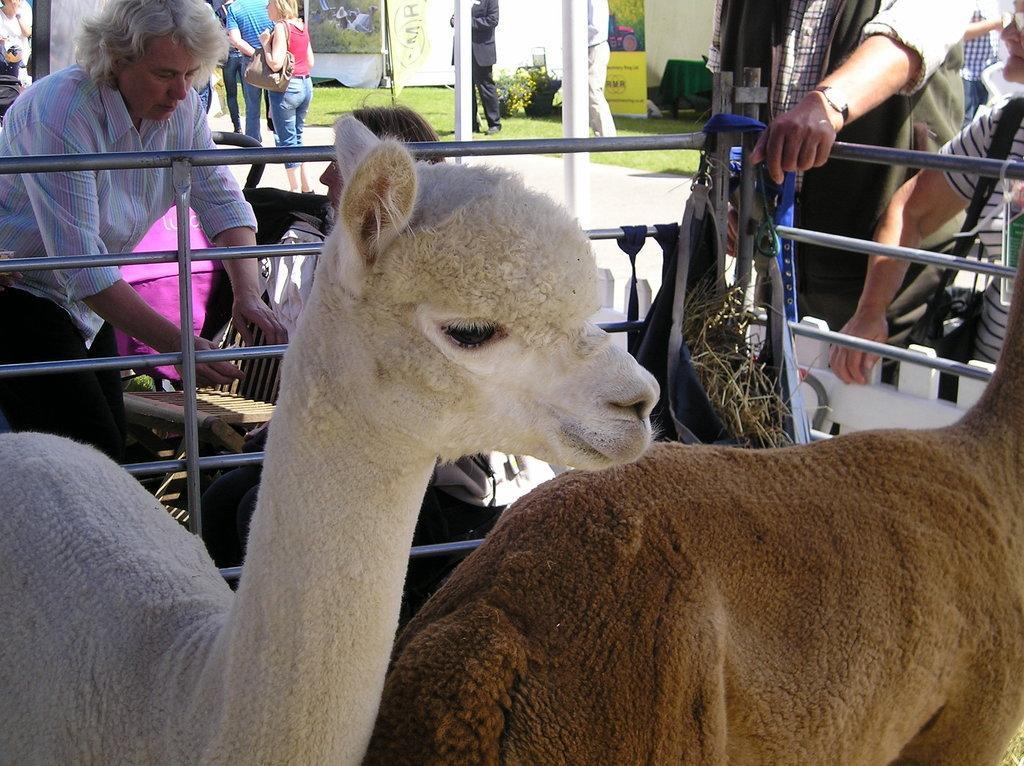Please provide a concise description of this image. In this image in the front there are animals. In the center there is a railing. In the background there are persons standing, there is grass on the ground and there are boards with some text written on it and there are poles and in the center behind the railing, there is a man sitting and there is an empty chair. 